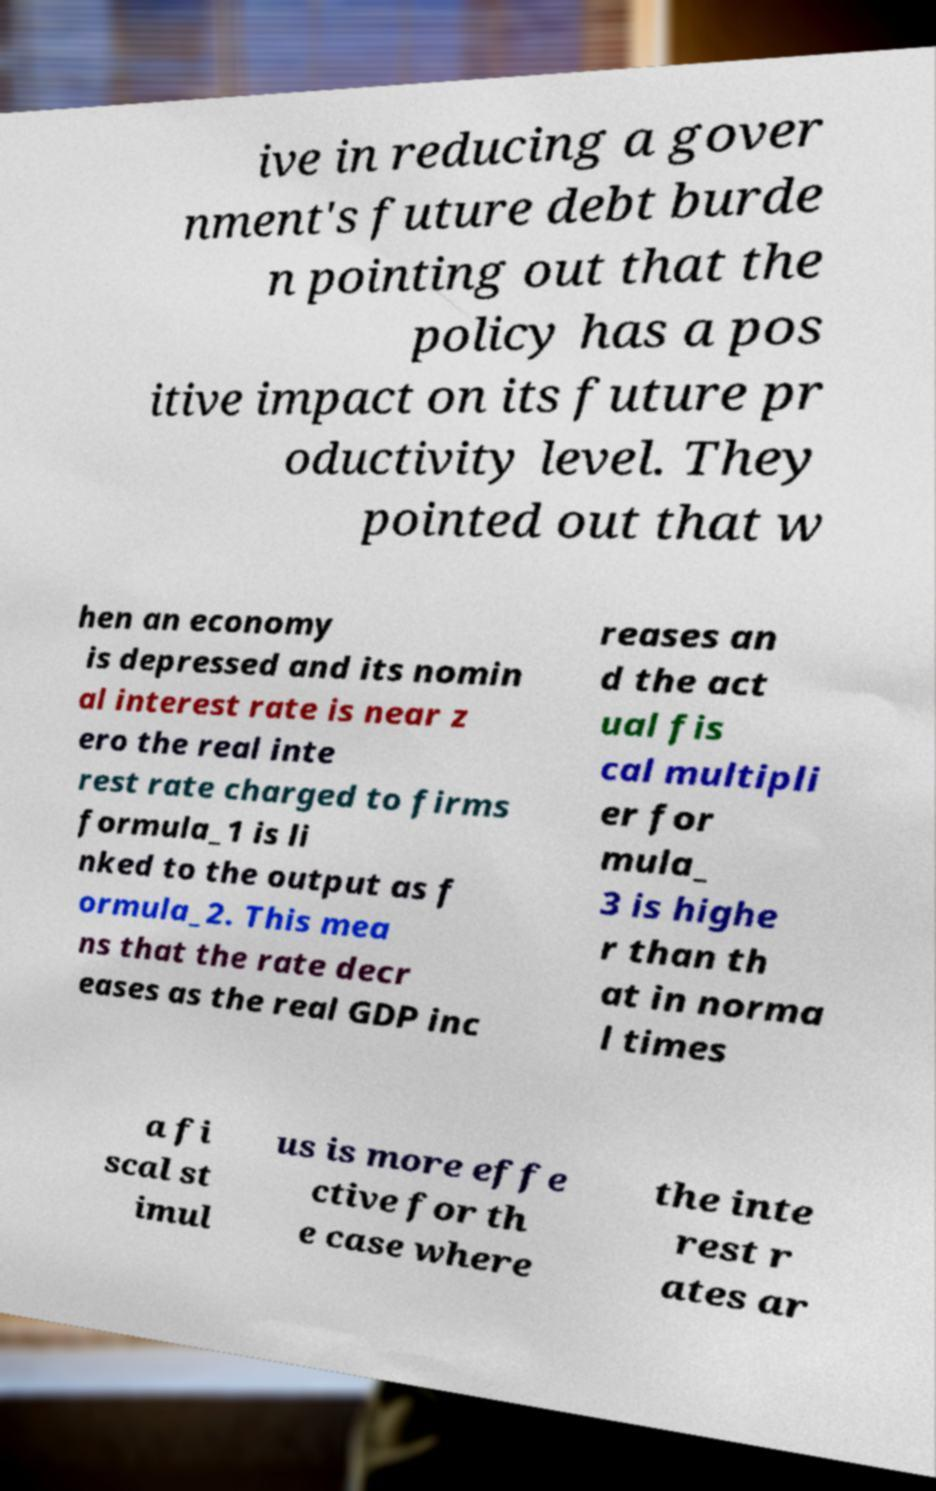Please identify and transcribe the text found in this image. ive in reducing a gover nment's future debt burde n pointing out that the policy has a pos itive impact on its future pr oductivity level. They pointed out that w hen an economy is depressed and its nomin al interest rate is near z ero the real inte rest rate charged to firms formula_1 is li nked to the output as f ormula_2. This mea ns that the rate decr eases as the real GDP inc reases an d the act ual fis cal multipli er for mula_ 3 is highe r than th at in norma l times a fi scal st imul us is more effe ctive for th e case where the inte rest r ates ar 